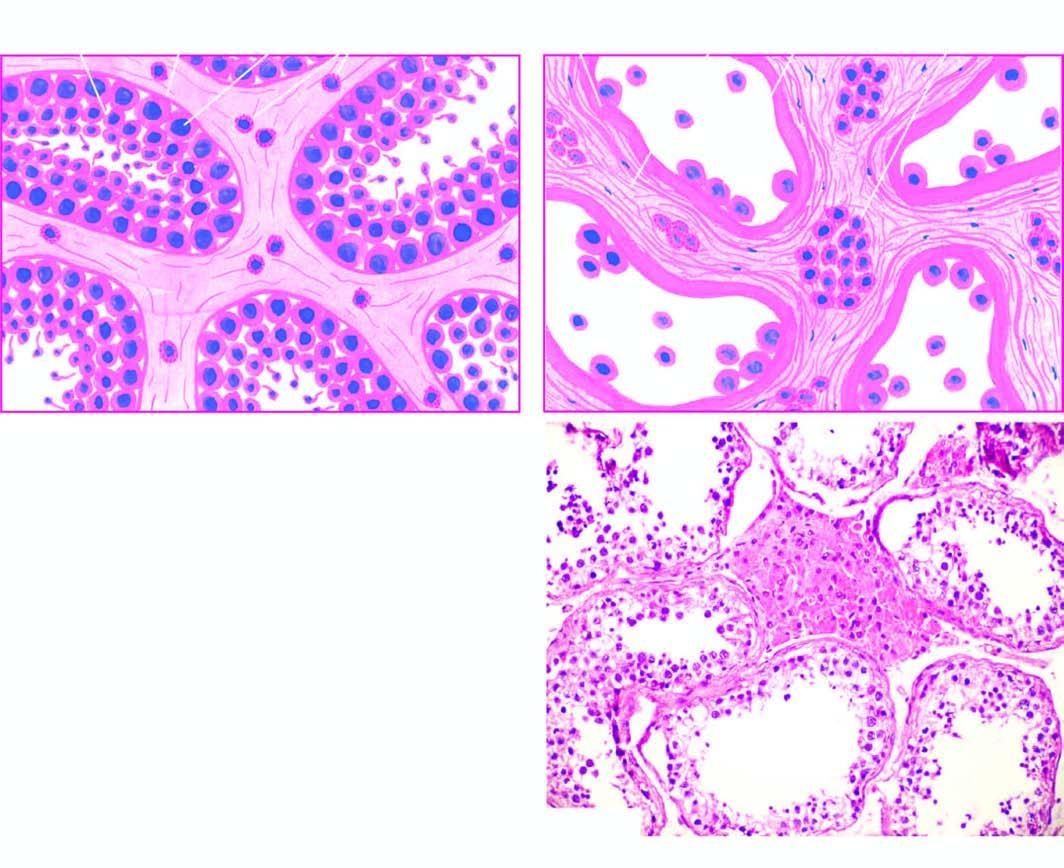s adp contrasted with that of cryptorchid testis?
Answer the question using a single word or phrase. No 